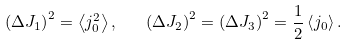Convert formula to latex. <formula><loc_0><loc_0><loc_500><loc_500>\left ( \Delta J _ { 1 } \right ) ^ { 2 } = \left \langle j ^ { 2 } _ { 0 } \right \rangle , \quad \left ( \Delta J _ { 2 } \right ) ^ { 2 } = \left ( \Delta J _ { 3 } \right ) ^ { 2 } = \frac { 1 } { 2 } \left \langle j _ { 0 } \right \rangle .</formula> 